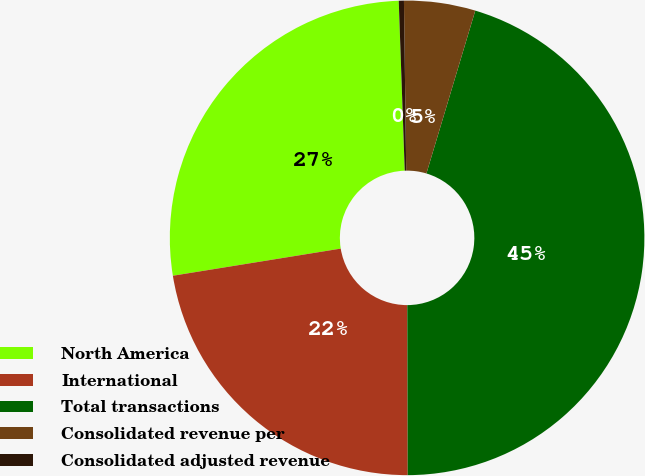Convert chart to OTSL. <chart><loc_0><loc_0><loc_500><loc_500><pie_chart><fcel>North America<fcel>International<fcel>Total transactions<fcel>Consolidated revenue per<fcel>Consolidated adjusted revenue<nl><fcel>26.99%<fcel>22.49%<fcel>45.32%<fcel>4.85%<fcel>0.35%<nl></chart> 